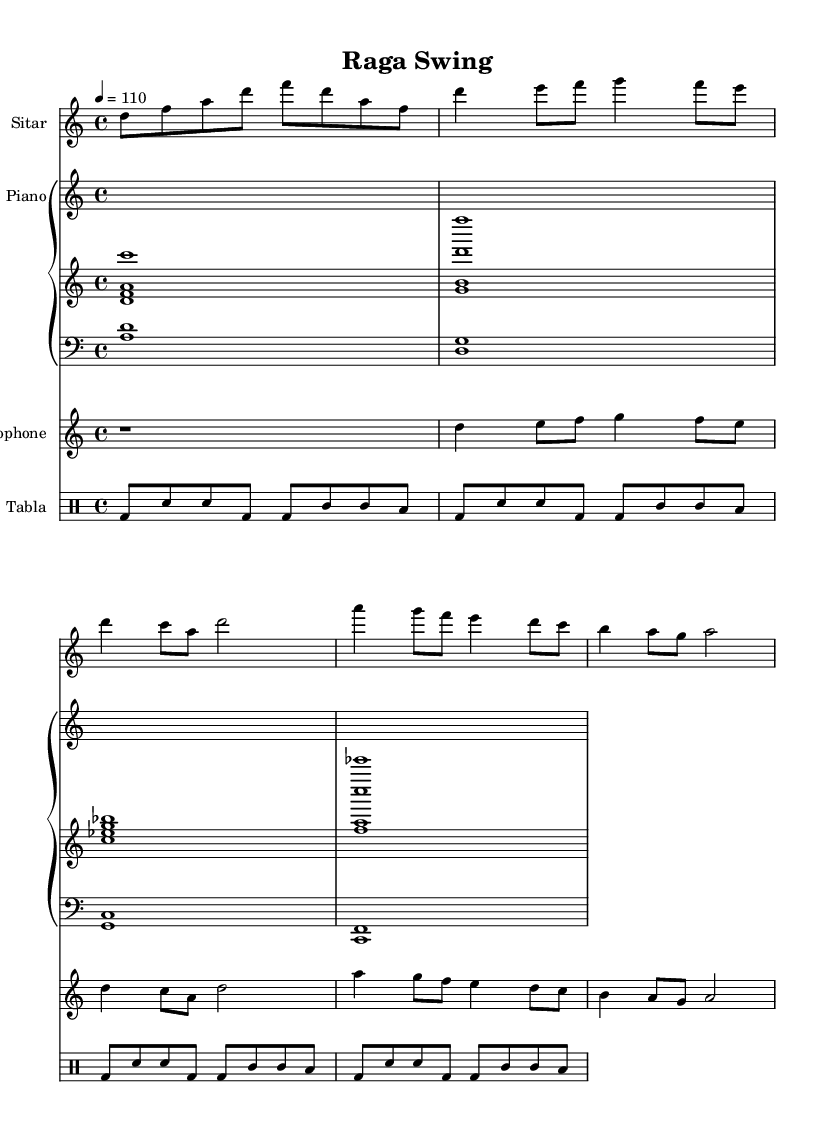What is the key signature of this music? The key signature indicated in the sheet music is D minor, which corresponds to the D dorian mode as noted in the global settings. Therefore, one flat (B flat) would typically be present in the key signature for the D minor scale.
Answer: D minor What is the time signature of the piece? The time signature is displayed clearly in the global settings. It is set as 4/4, which indicates four beats per measure with a quarter note receiving one beat.
Answer: 4/4 What is the tempo marking for this piece? The tempo marking is found in the global settings where it states "4 = 110". This means that each quarter note is to be played at a speed of 110 beats per minute.
Answer: 110 How many measures does the sitar part have? By analyzing the sitar part, counting each segment separated by the vertical line indicates that there are 5 distinct measures present in the sheet music for the sitar.
Answer: 5 What instruments are featured in this fusion piece? The instruments are listed and can be identified from the individual parts labeled in the sheet music. They include sitar, piano, saxophone, and tabla.
Answer: Sitar, piano, saxophone, tabla Which section corresponds to the tabla part? The tabla section is labeled as "Tabla" in the sheet music. The drummode notation used specifies the rhythmic patterns associated with the tabla directly following its instrumental header.
Answer: Tabla What is the relationship between the piano and saxophone parts? The piano part and the saxophone part play harmoniously alongside each other, with the saxophone primarily carrying the melody while the piano provides harmonic support and rhythmic complexity. The soprano saxophone complements the piano chords.
Answer: Harmony and melody 